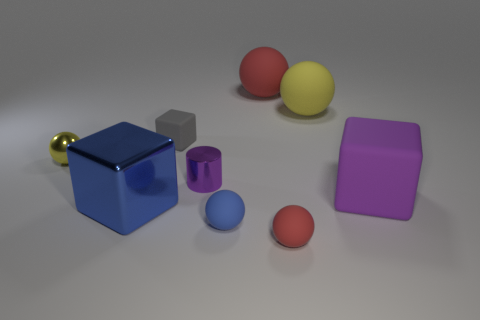Subtract all blue spheres. How many spheres are left? 4 Subtract all tiny red rubber spheres. How many spheres are left? 4 Subtract all gray spheres. Subtract all yellow blocks. How many spheres are left? 5 Add 1 red objects. How many objects exist? 10 Subtract all spheres. How many objects are left? 4 Add 6 small blue objects. How many small blue objects exist? 7 Subtract 1 gray cubes. How many objects are left? 8 Subtract all big yellow rubber spheres. Subtract all red objects. How many objects are left? 6 Add 4 big blue things. How many big blue things are left? 5 